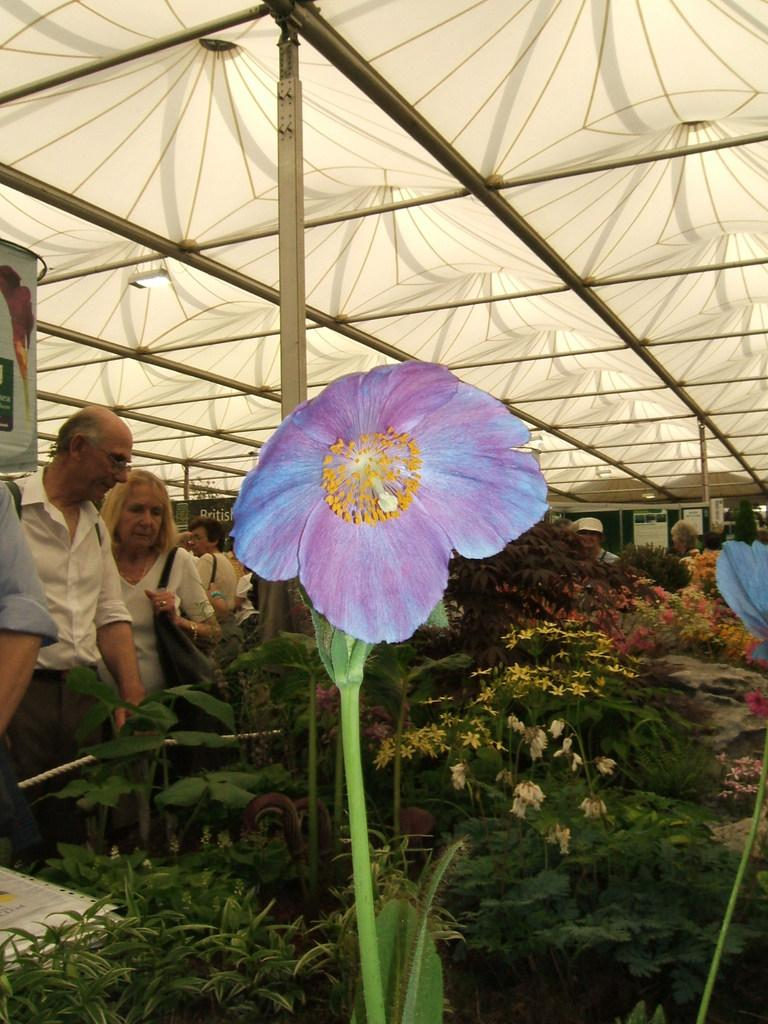What type of plant can be seen in the image? There is a flower with a stem in the image. What can be seen in the distance behind the flower? There are many trees in the background of the image. Are there any human figures in the image? Yes, there are people in the image. What color is the roof visible in the image? There is a white-colored roof in the image. How many feet are visible in the image? There is no mention of feet in the image, so it cannot be determined how many are visible. 